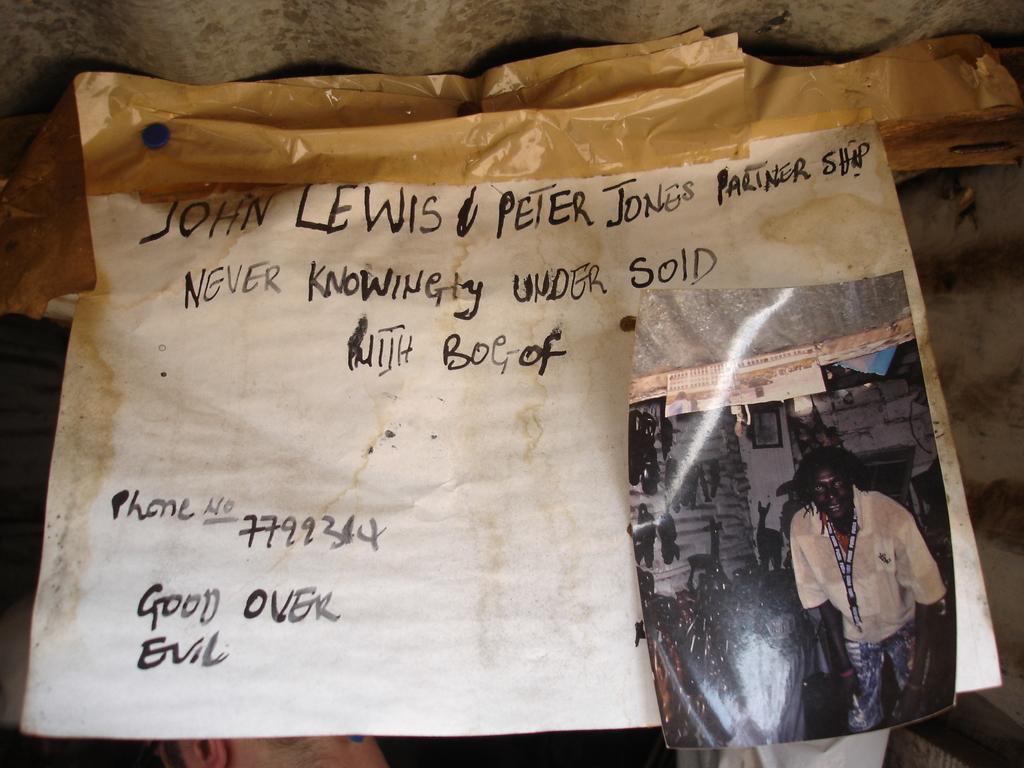Describe this image in one or two sentences. In the center of the picture there is a chart and there is a photograph. At the top there are nails and sticker. 